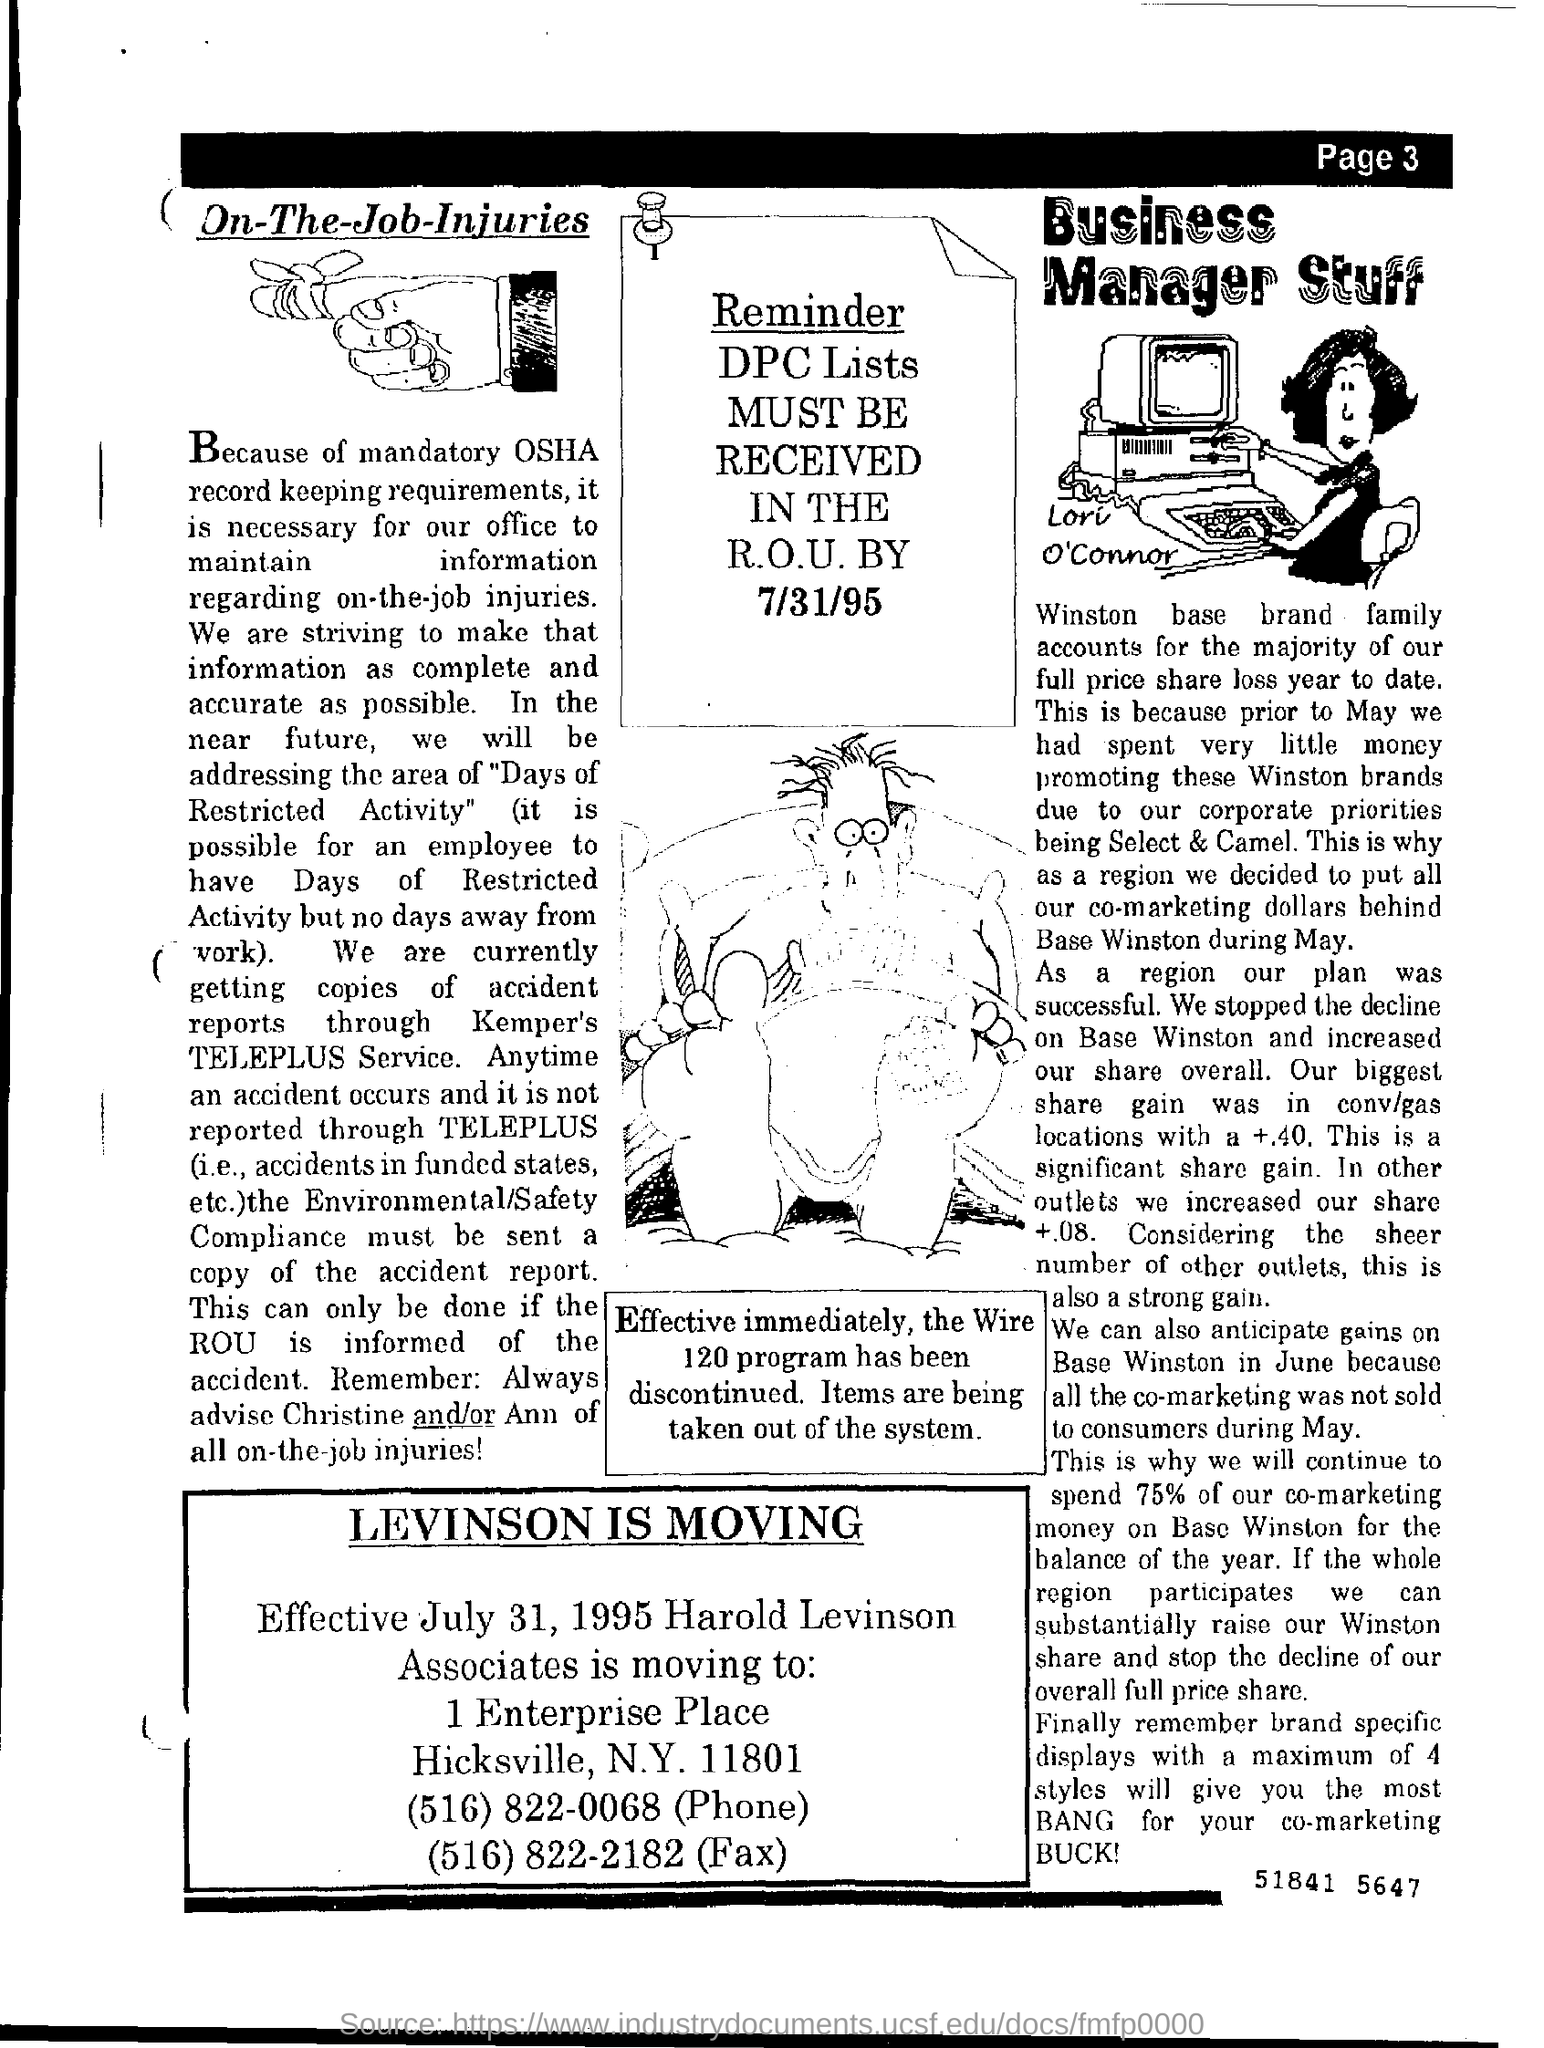What is the Phone Number mentioned in the document?
Make the answer very short. (516) 822-0068. 